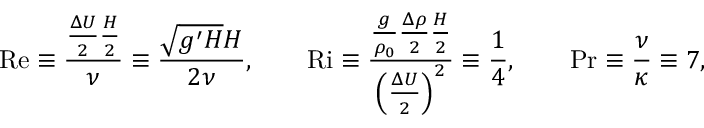Convert formula to latex. <formula><loc_0><loc_0><loc_500><loc_500>R e \equiv \frac { \frac { \Delta U } { 2 } \frac { H } { 2 } } { \nu } \equiv \frac { \sqrt { g ^ { \prime } H } H } { 2 \nu } , \quad R i \equiv \frac { \frac { g } { \rho _ { 0 } } \frac { \Delta \rho } { 2 } \frac { H } { 2 } } { \left ( \frac { \Delta U } { 2 } \right ) ^ { 2 } } \equiv \frac { 1 } { 4 } , \quad P r \equiv \frac { \nu } { \kappa } \equiv 7 ,</formula> 